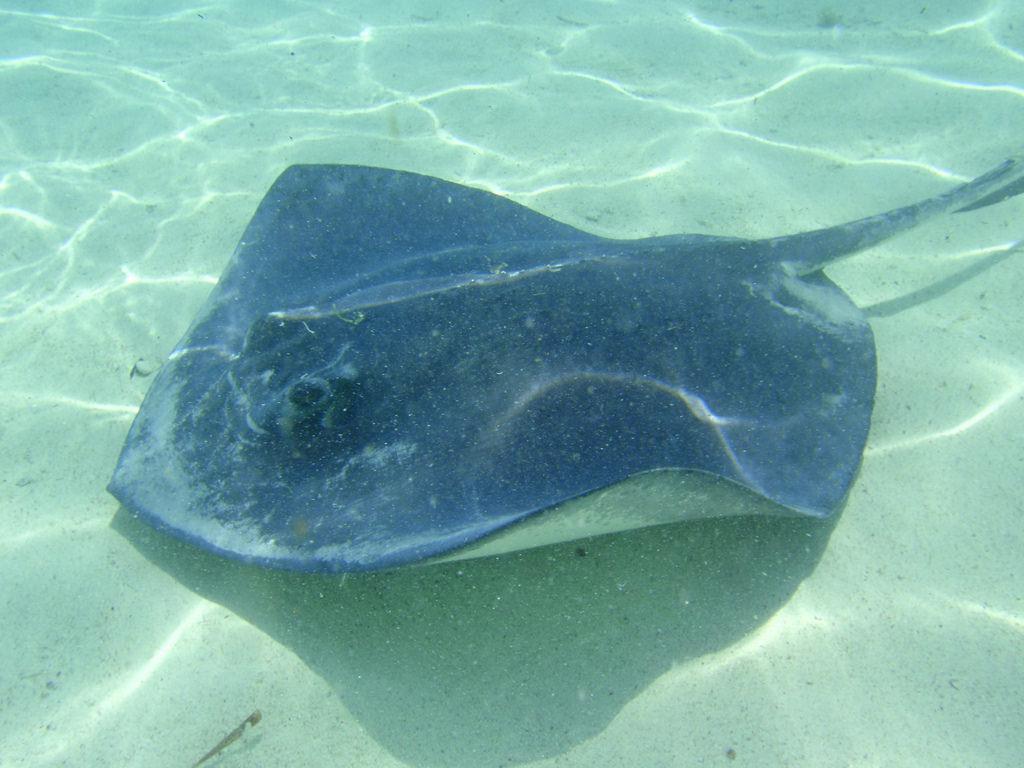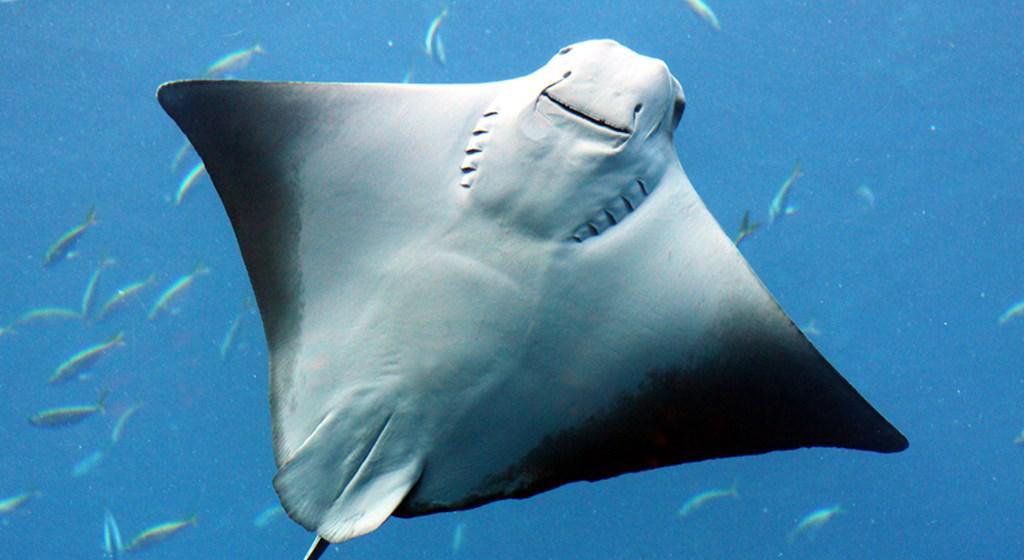The first image is the image on the left, the second image is the image on the right. Assess this claim about the two images: "At least one stingray's underside is visible.". Correct or not? Answer yes or no. Yes. 